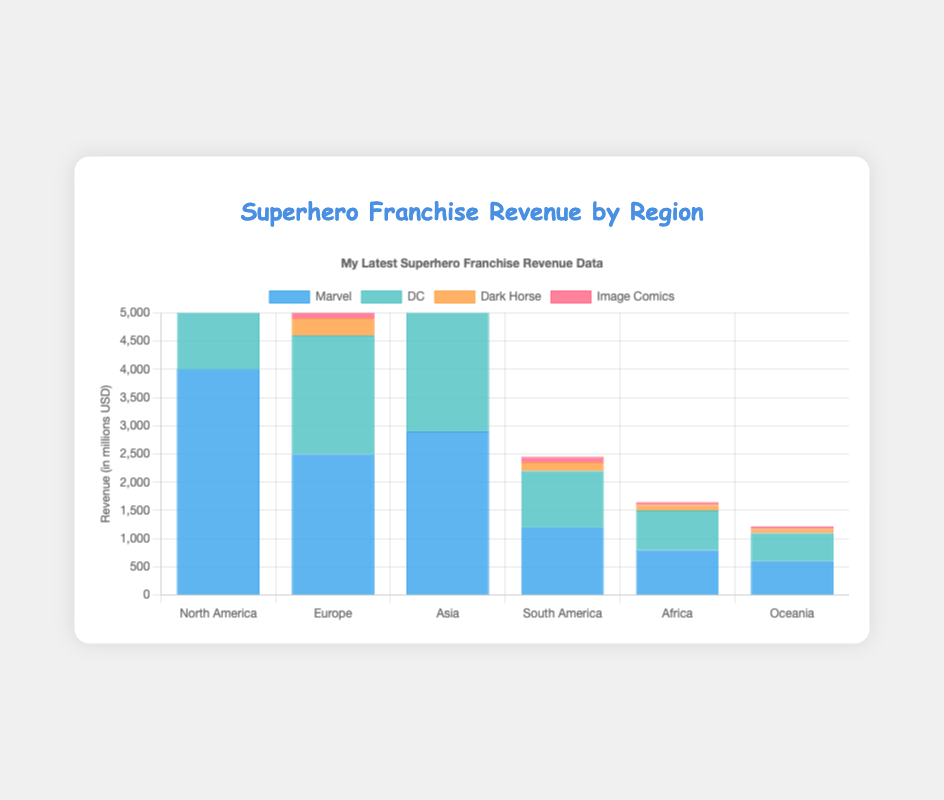Which region has the highest revenue for Marvel? By examining the height of the blue bars for Marvel in each region, the bar for North America is the tallest, indicating the highest revenue.
Answer: North America What is the total revenue for DC across all regions? Add the revenue for DC from each region: 3200 (North America) + 2100 (Europe) + 2300 (Asia) + 1000 (South America) + 700 (Africa) + 500 (Oceania) = 9800.
Answer: 9800 Compare the revenue of Dark Horse and Image Comics in Asia. Which one is higher and by how much? The bar for Dark Horse in Asia is 400, while for Image Comics it is 250. Subtracting these values gives 400 - 250 = 150.
Answer: Dark Horse by 150 Which two regions have the closest revenue values for Marvel? Comparing the heights of the blue bars, Africa (800) and Oceania (600) show the closest values, with a difference of 800 - 600 = 200.
Answer: Africa and Oceania What is the combined revenue for all companies in Europe? Add the revenues for Marvel (2500), DC (2100), Dark Horse (300), and Image Comics (200) in Europe: 2500 + 2100 + 300 + 200 = 5100.
Answer: 5100 Which company has the lowest revenue in South America and what is the amount? The shortest bar in South America represents Image Comics, with a revenue of 100.
Answer: Image Comics, 100 What is the average revenue for Image Comics across all regions? Sum the Image Comics revenue values: 300 (North America) + 200 (Europe) + 250 (Asia) + 100 (South America) + 50 (Africa) + 45 (Oceania) = 945, then divide by 6 regions: 945 / 6 = 157.5.
Answer: 157.5 How does North America's revenue for Dark Horse compare to Oceania's revenue for Marvel? North America's Dark Horse revenue is 500, while Oceania's Marvel revenue is 600, thus 500 < 600.
Answer: Lower If you were to rank the regions by Marvel's revenue, which region would rank third? North America (4000), Asia (2900), Europe (2500), South America (1200), Africa (800), Oceania (600). The third highest is Europe with 2500.
Answer: Europe 